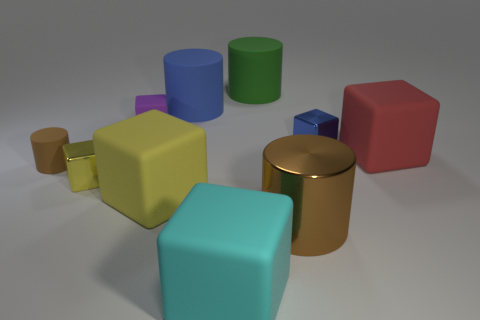Are there any other things that have the same size as the green rubber cylinder?
Your response must be concise. Yes. The other tiny block that is the same material as the red block is what color?
Offer a very short reply. Purple. There is a cylinder that is in front of the tiny brown thing; is its color the same as the big cube behind the big yellow thing?
Offer a very short reply. No. What number of cubes are either big gray objects or green matte objects?
Offer a terse response. 0. Are there an equal number of small yellow things in front of the yellow shiny thing and large cyan matte things?
Offer a terse response. No. The thing that is right of the metal cube that is on the right side of the large green rubber cylinder that is behind the small purple rubber cube is made of what material?
Provide a succinct answer. Rubber. There is a thing that is the same color as the metallic cylinder; what is it made of?
Give a very brief answer. Rubber. What number of things are cylinders in front of the yellow shiny cube or small brown rubber things?
Ensure brevity in your answer.  2. How many things are either big green matte blocks or blocks that are left of the small purple thing?
Provide a succinct answer. 1. There is a big block behind the metal block that is in front of the red thing; what number of cylinders are in front of it?
Keep it short and to the point. 2. 